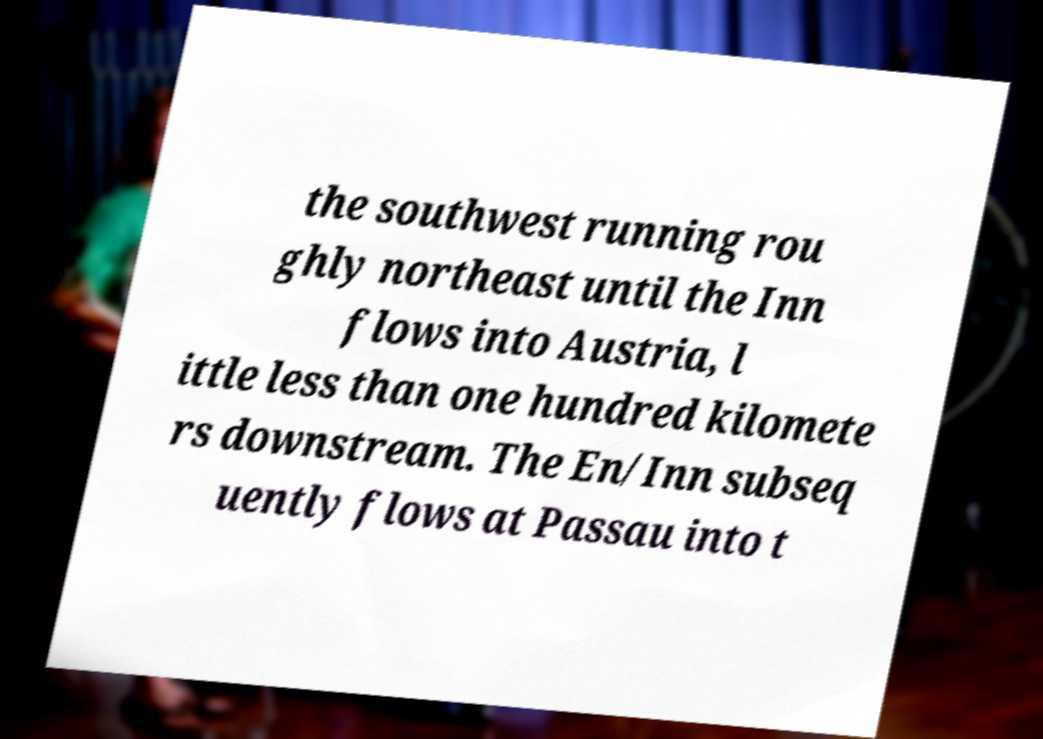Could you assist in decoding the text presented in this image and type it out clearly? the southwest running rou ghly northeast until the Inn flows into Austria, l ittle less than one hundred kilomete rs downstream. The En/Inn subseq uently flows at Passau into t 